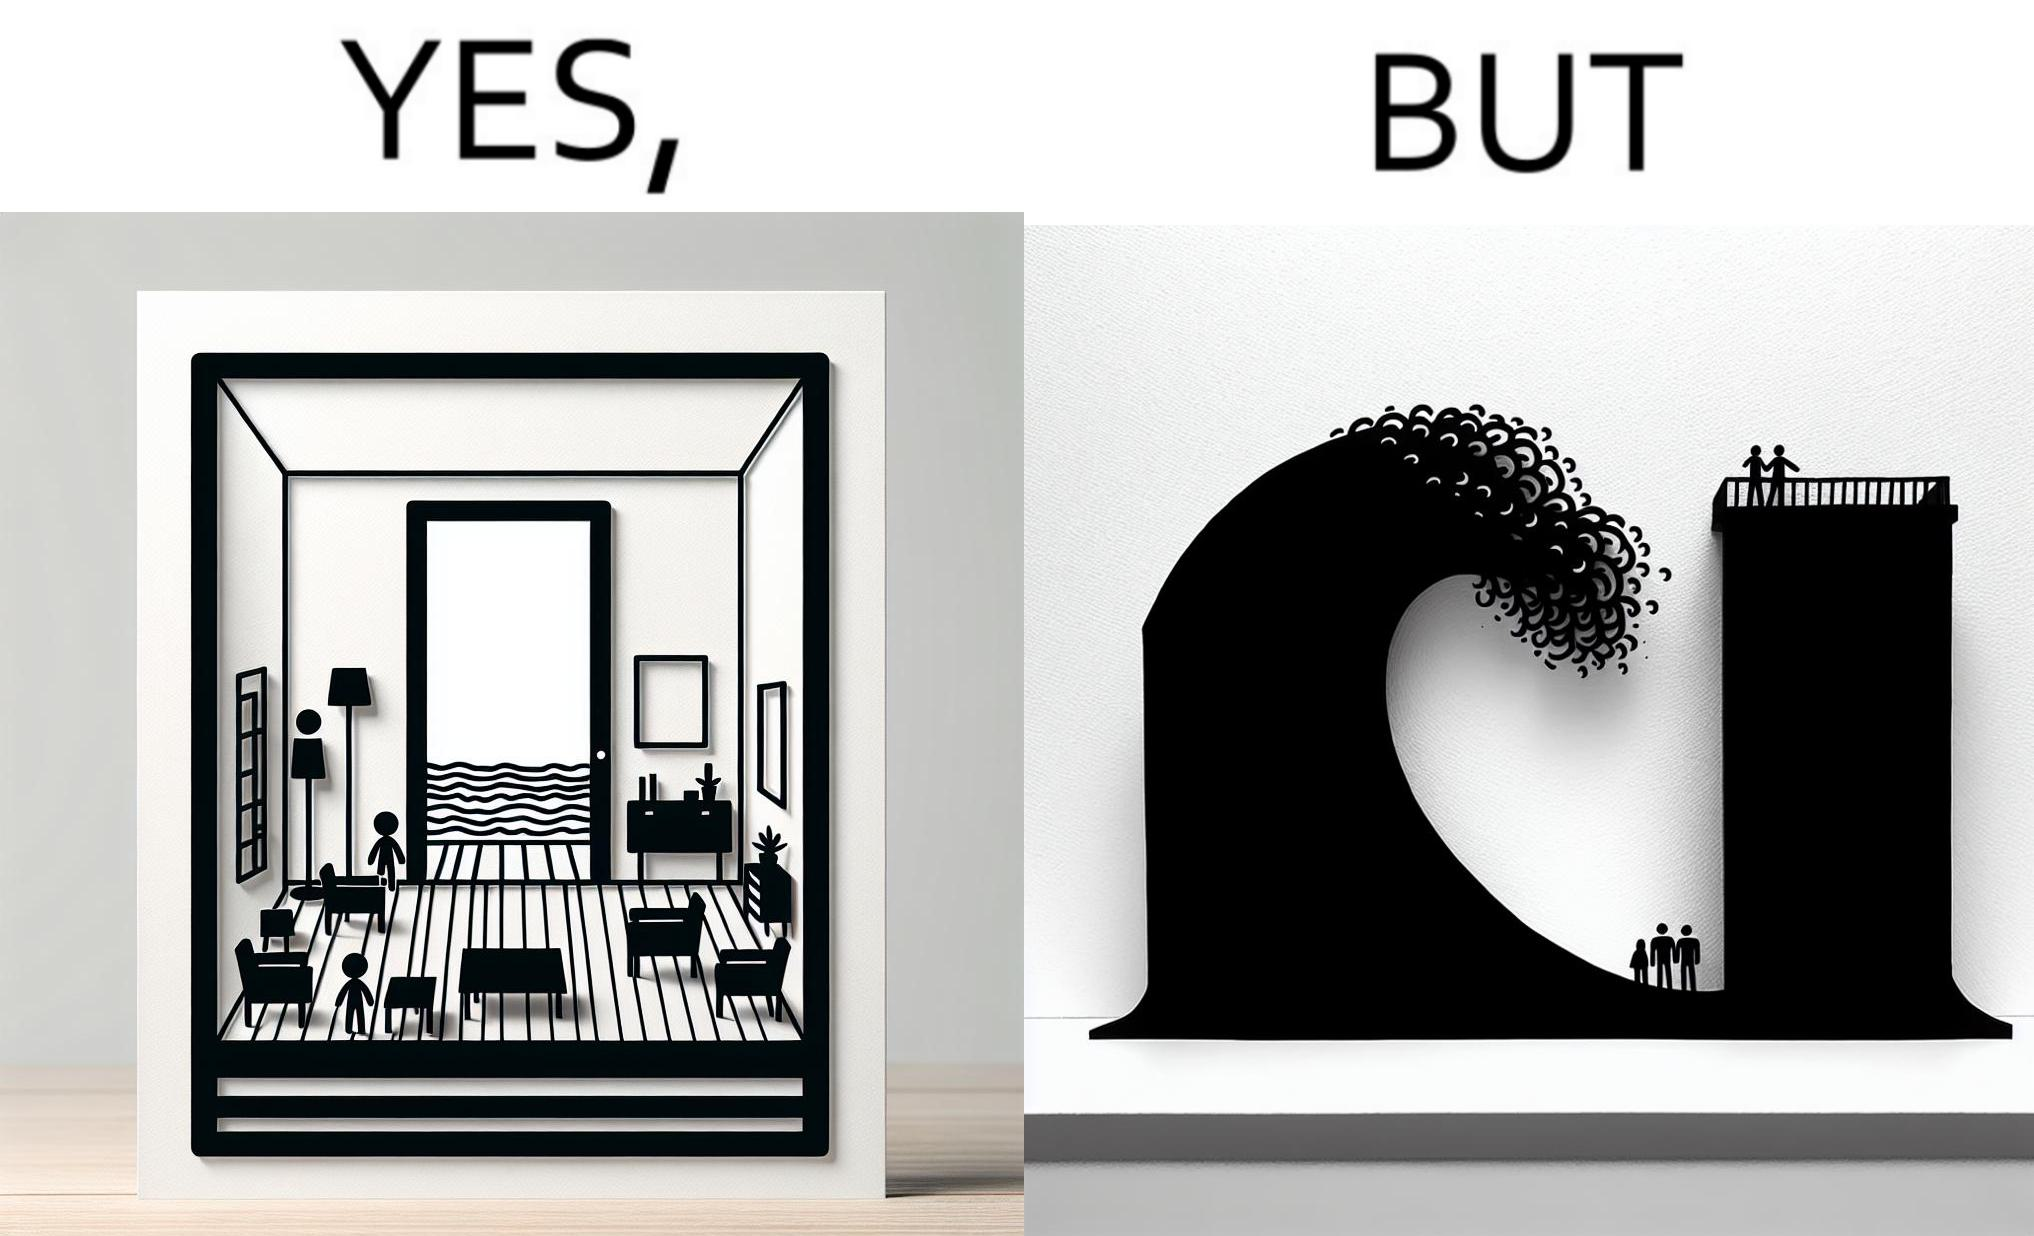Compare the left and right sides of this image. In the left part of the image: a room with a sea-facing door In the right part of the image: high waves in the sea twice of the height of the building near the sea 